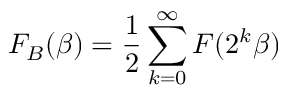Convert formula to latex. <formula><loc_0><loc_0><loc_500><loc_500>F _ { B } ( \beta ) = \frac { 1 } { 2 } \sum _ { k = 0 } ^ { \infty } F ( 2 ^ { k } \beta )</formula> 